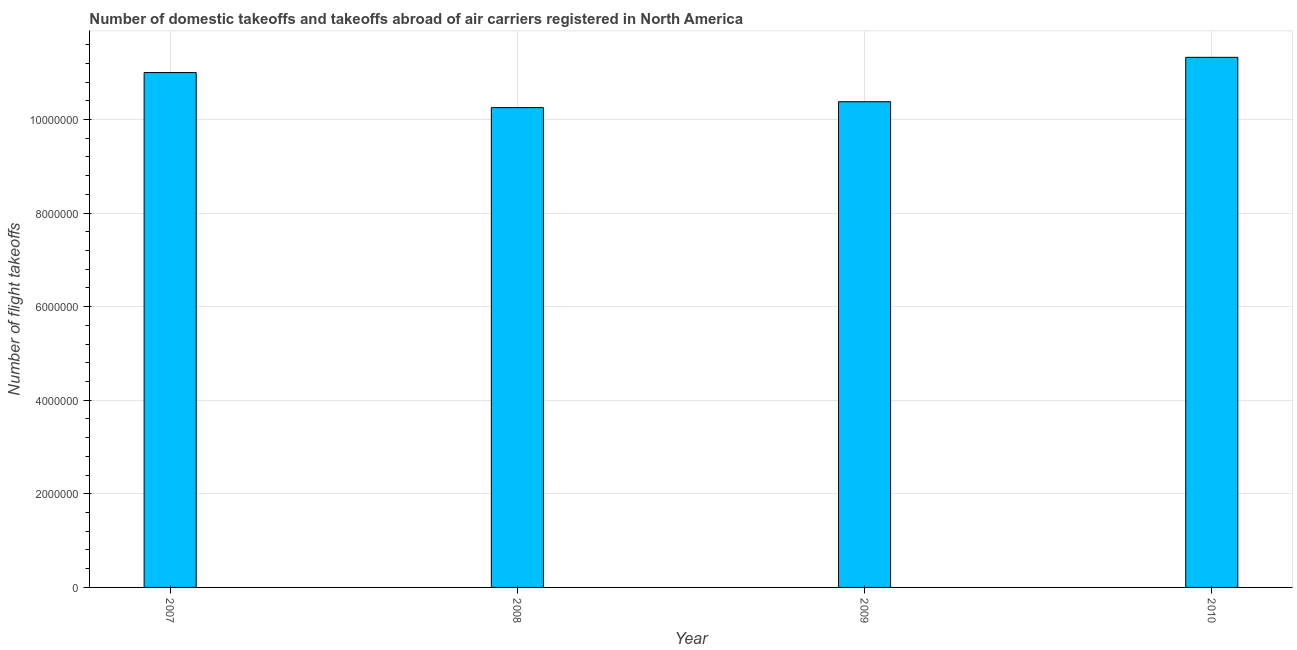Does the graph contain grids?
Give a very brief answer. Yes. What is the title of the graph?
Make the answer very short. Number of domestic takeoffs and takeoffs abroad of air carriers registered in North America. What is the label or title of the Y-axis?
Give a very brief answer. Number of flight takeoffs. What is the number of flight takeoffs in 2010?
Give a very brief answer. 1.13e+07. Across all years, what is the maximum number of flight takeoffs?
Offer a very short reply. 1.13e+07. Across all years, what is the minimum number of flight takeoffs?
Ensure brevity in your answer.  1.03e+07. In which year was the number of flight takeoffs maximum?
Make the answer very short. 2010. In which year was the number of flight takeoffs minimum?
Provide a succinct answer. 2008. What is the sum of the number of flight takeoffs?
Your response must be concise. 4.30e+07. What is the difference between the number of flight takeoffs in 2008 and 2010?
Provide a succinct answer. -1.07e+06. What is the average number of flight takeoffs per year?
Your answer should be compact. 1.07e+07. What is the median number of flight takeoffs?
Ensure brevity in your answer.  1.07e+07. What is the ratio of the number of flight takeoffs in 2007 to that in 2008?
Offer a terse response. 1.07. Is the number of flight takeoffs in 2008 less than that in 2010?
Keep it short and to the point. Yes. What is the difference between the highest and the second highest number of flight takeoffs?
Make the answer very short. 3.25e+05. What is the difference between the highest and the lowest number of flight takeoffs?
Ensure brevity in your answer.  1.07e+06. In how many years, is the number of flight takeoffs greater than the average number of flight takeoffs taken over all years?
Offer a very short reply. 2. Are all the bars in the graph horizontal?
Provide a short and direct response. No. How many years are there in the graph?
Your answer should be very brief. 4. What is the difference between two consecutive major ticks on the Y-axis?
Provide a short and direct response. 2.00e+06. Are the values on the major ticks of Y-axis written in scientific E-notation?
Give a very brief answer. No. What is the Number of flight takeoffs in 2007?
Give a very brief answer. 1.10e+07. What is the Number of flight takeoffs in 2008?
Your answer should be very brief. 1.03e+07. What is the Number of flight takeoffs in 2009?
Your answer should be compact. 1.04e+07. What is the Number of flight takeoffs of 2010?
Your answer should be very brief. 1.13e+07. What is the difference between the Number of flight takeoffs in 2007 and 2008?
Your answer should be compact. 7.50e+05. What is the difference between the Number of flight takeoffs in 2007 and 2009?
Give a very brief answer. 6.24e+05. What is the difference between the Number of flight takeoffs in 2007 and 2010?
Ensure brevity in your answer.  -3.25e+05. What is the difference between the Number of flight takeoffs in 2008 and 2009?
Keep it short and to the point. -1.26e+05. What is the difference between the Number of flight takeoffs in 2008 and 2010?
Your answer should be compact. -1.07e+06. What is the difference between the Number of flight takeoffs in 2009 and 2010?
Your answer should be very brief. -9.49e+05. What is the ratio of the Number of flight takeoffs in 2007 to that in 2008?
Your answer should be compact. 1.07. What is the ratio of the Number of flight takeoffs in 2007 to that in 2009?
Ensure brevity in your answer.  1.06. What is the ratio of the Number of flight takeoffs in 2008 to that in 2010?
Provide a short and direct response. 0.91. What is the ratio of the Number of flight takeoffs in 2009 to that in 2010?
Keep it short and to the point. 0.92. 